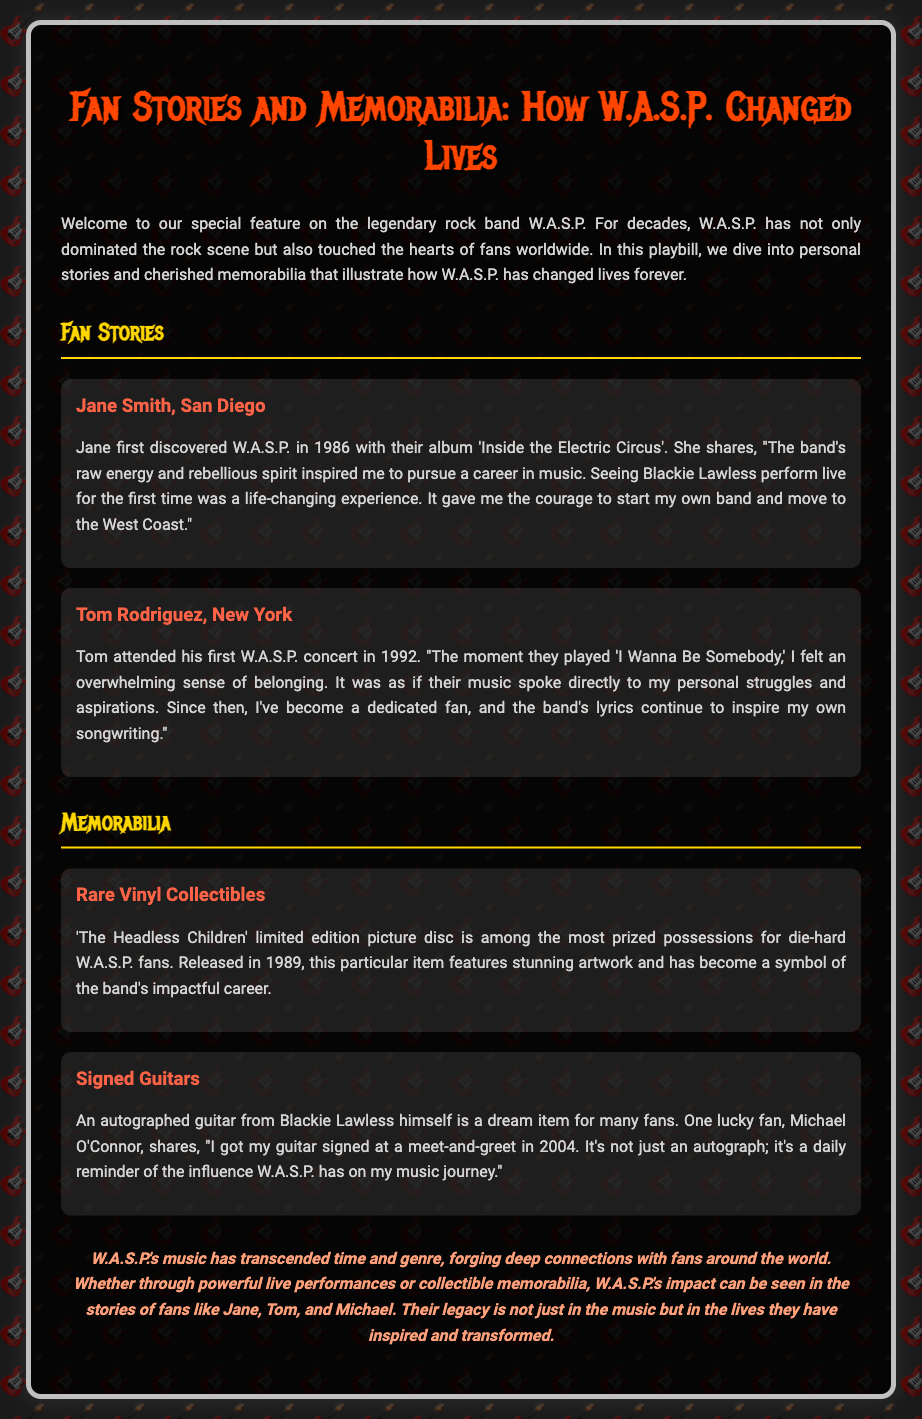What year did Jane Smith first discover W.A.S.P.? Jane discovered W.A.S.P. in 1986, as mentioned in her story.
Answer: 1986 What album did Jane listen to when she first discovered W.A.S.P.? Jane mentioned that she discovered W.A.S.P. with the album 'Inside the Electric Circus'.
Answer: 'Inside the Electric Circus' What was Tom Rodriguez's first W.A.S.P. concert year? Tom's first concert was in 1992, which is stated in his story.
Answer: 1992 Who signed the guitar owned by Michael O'Connor? The guitar was signed by Blackie Lawless, according to the memorabilia item.
Answer: Blackie Lawless What limited edition vinyl is mentioned in the document? The document refers to 'The Headless Children' limited edition picture disc.
Answer: 'The Headless Children' What emotion did Tom feel during the song "I Wanna Be Somebody"? Tom felt an overwhelming sense of belonging during that song, based on his story.
Answer: Belonging What type of memorabilia do many fans dream of having? The document mentions that many fans dream of having autographed guitars.
Answer: Autographed guitars How did Jane's experience with W.A.S.P. impact her career? Jane's experience inspired her to pursue a career in music.
Answer: Pursue a career in music What is the significance of W.A.S.P. according to the playbill's conclusion? The playbill concludes that W.A.S.P.'s music has transcended time and genre, forging deep connections with fans.
Answer: Transcended time and genre 